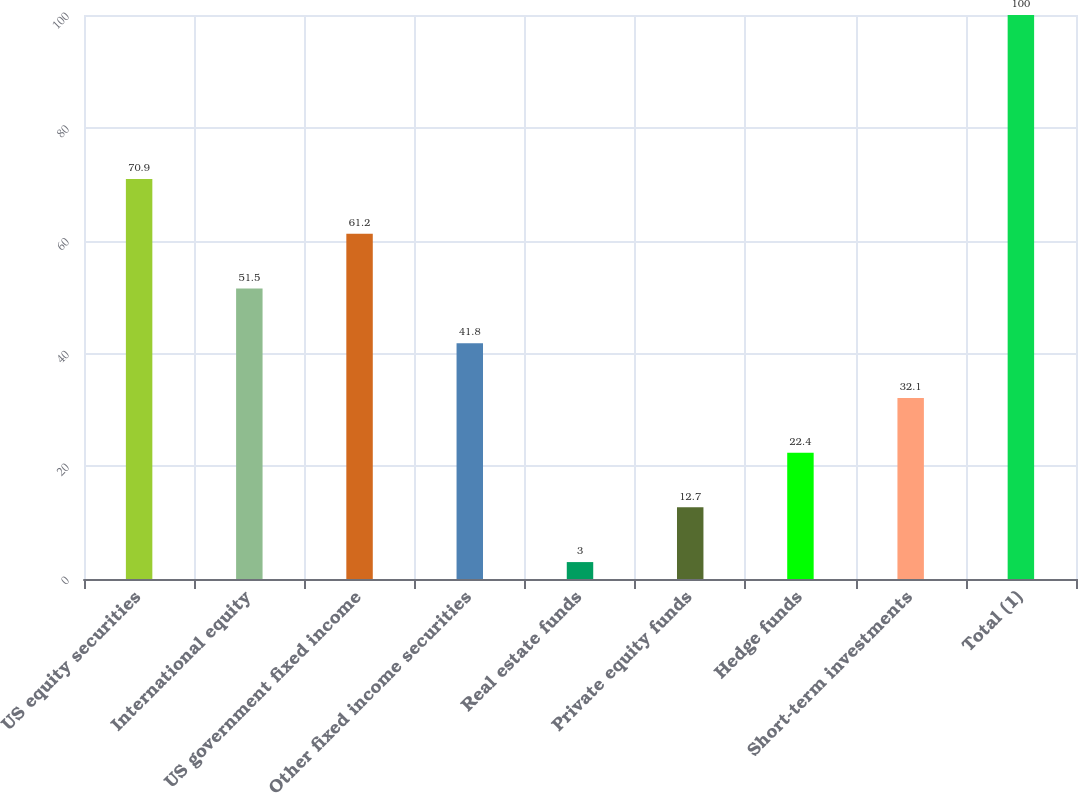Convert chart to OTSL. <chart><loc_0><loc_0><loc_500><loc_500><bar_chart><fcel>US equity securities<fcel>International equity<fcel>US government fixed income<fcel>Other fixed income securities<fcel>Real estate funds<fcel>Private equity funds<fcel>Hedge funds<fcel>Short-term investments<fcel>Total (1)<nl><fcel>70.9<fcel>51.5<fcel>61.2<fcel>41.8<fcel>3<fcel>12.7<fcel>22.4<fcel>32.1<fcel>100<nl></chart> 